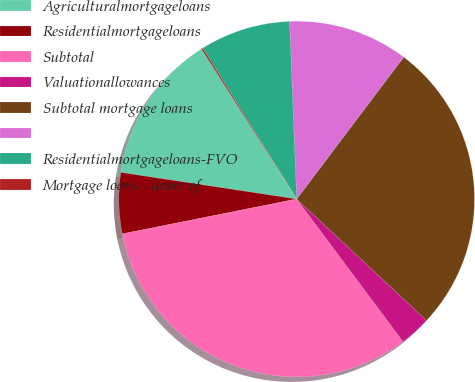Convert chart. <chart><loc_0><loc_0><loc_500><loc_500><pie_chart><fcel>Agriculturalmortgageloans<fcel>Residentialmortgageloans<fcel>Subtotal<fcel>Valuationallowances<fcel>Subtotal mortgage loans<fcel>Unnamed: 5<fcel>Residentialmortgageloans-FVO<fcel>Mortgage loans - lower of<nl><fcel>13.61%<fcel>5.53%<fcel>32.06%<fcel>2.84%<fcel>26.68%<fcel>10.92%<fcel>8.22%<fcel>0.14%<nl></chart> 